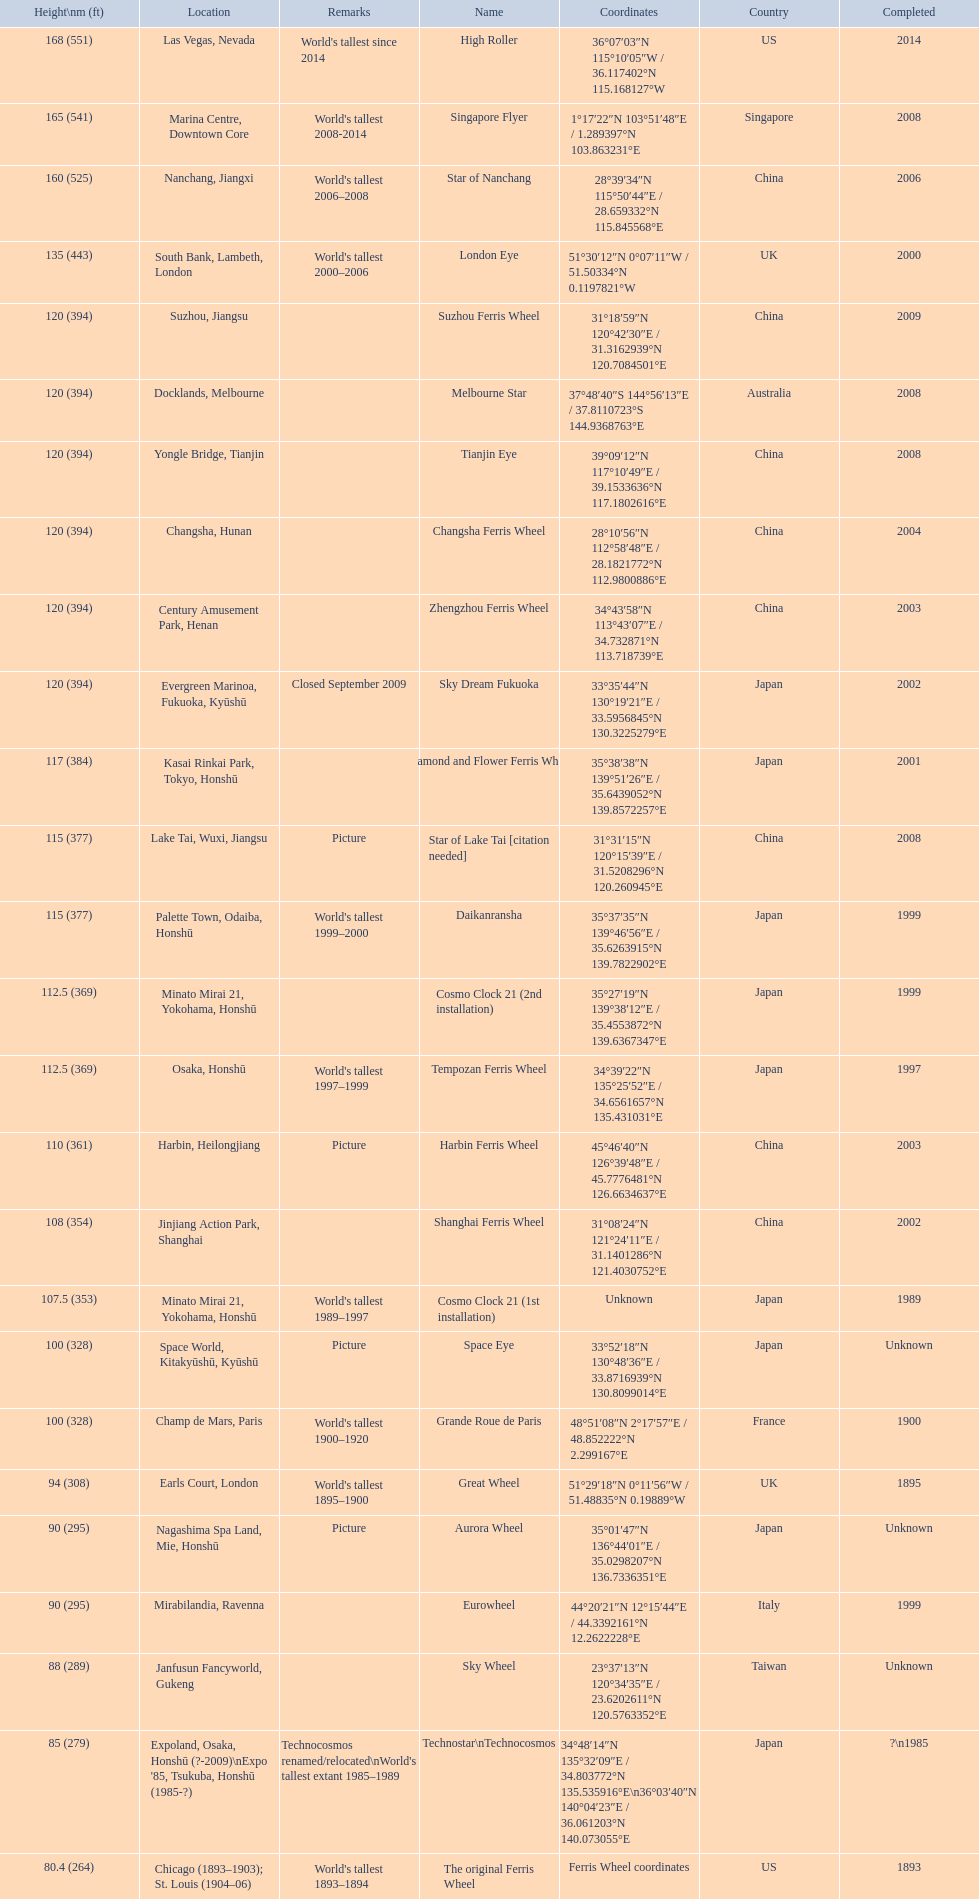How tall is the roller coaster star of nanchang? 165 (541). When was the roller coaster star of nanchang completed? 2008. What is the name of the oldest roller coaster? Star of Nanchang. 